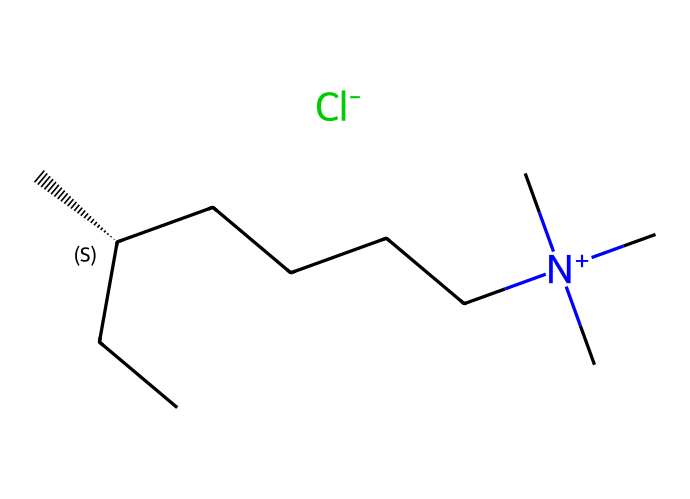How many carbon atoms are present in this ionic liquid structure? By analyzing the provided SMILES notation, we can count the carbon atoms represented by the letter "C." There are 10 carbon atoms in the structure, as indicated by their occurrences in the SMILES string.
Answer: 10 What is the charge of the nitrogen atom in this ionic liquid? The nitrogen atom is denoted with a plus sign "[N+]" in the SMILES structure, indicating it carries a positive charge. This is a typical characteristic of cations in ionic liquids.
Answer: positive What anion is paired with the cation in this ionic liquid? The "[Cl-]" at the end of the SMILES representation indicates that the anion present is chloride, which is a common counterion for many ionic liquids.
Answer: chloride How many branches does the alkyl chain have in this ionic liquid? The structure features a branched alkyl chain represented by "(C)(CC)" connected to the central chiral carbon "[C@H]." This indicates there are two branches off the main chain.
Answer: 2 What feature of this ionic liquid contributes to its low volatility? The presence of ionic bonds in the structure, particularly the positive nitrogen and negative chloride ion, creates a strong attraction between ions, leading to lower volatility. This differs from traditional solvents.
Answer: ionic bonds What type of solvent property can be expected from this ionic liquid based on its structure? The extensive carbon chain and ionic nature suggest it is likely to be a good solvent for polar and non-polar substances due to its unique polar and apolar characteristics.
Answer: good solvent 